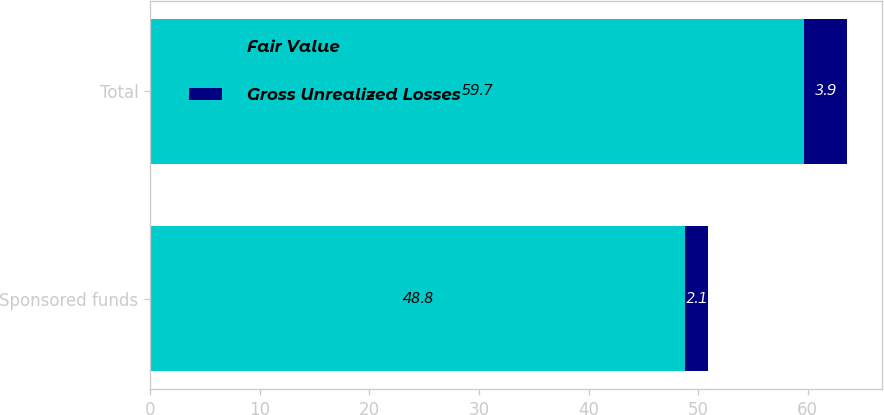<chart> <loc_0><loc_0><loc_500><loc_500><stacked_bar_chart><ecel><fcel>Sponsored funds<fcel>Total<nl><fcel>Fair Value<fcel>48.8<fcel>59.7<nl><fcel>Gross Unrealized Losses<fcel>2.1<fcel>3.9<nl></chart> 